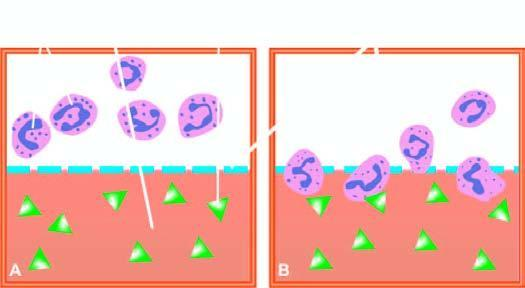what is separated from test solution below?
Answer the question using a single word or phrase. Suspension of leucocytes above 